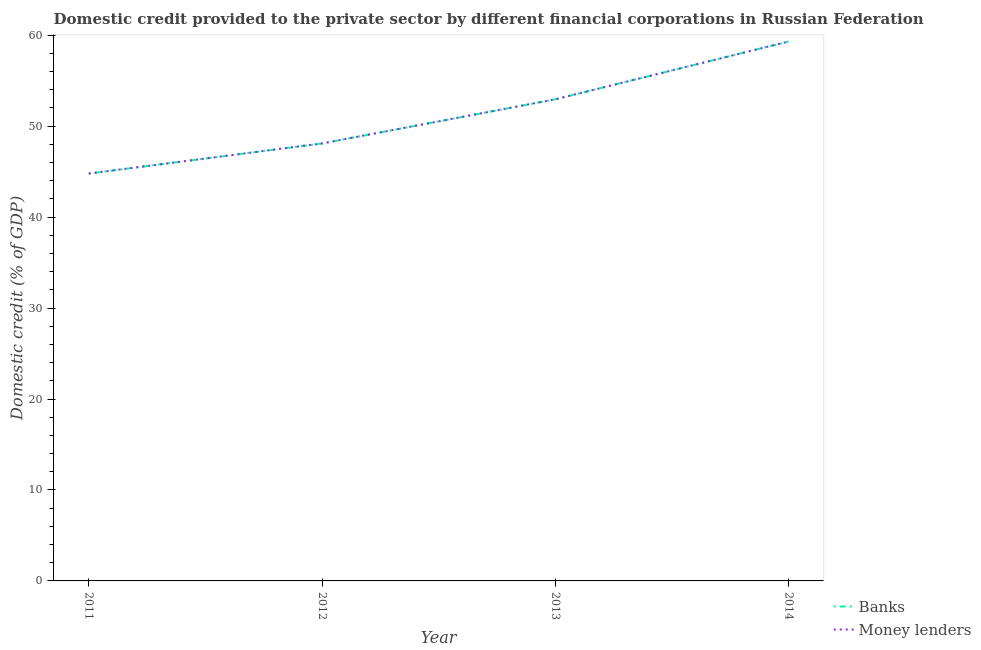What is the domestic credit provided by money lenders in 2013?
Your response must be concise. 52.96. Across all years, what is the maximum domestic credit provided by money lenders?
Ensure brevity in your answer.  59.31. Across all years, what is the minimum domestic credit provided by money lenders?
Keep it short and to the point. 44.79. What is the total domestic credit provided by money lenders in the graph?
Ensure brevity in your answer.  205.15. What is the difference between the domestic credit provided by money lenders in 2011 and that in 2013?
Make the answer very short. -8.17. What is the difference between the domestic credit provided by money lenders in 2012 and the domestic credit provided by banks in 2014?
Offer a terse response. -11.21. What is the average domestic credit provided by banks per year?
Offer a very short reply. 51.29. In the year 2013, what is the difference between the domestic credit provided by banks and domestic credit provided by money lenders?
Your answer should be compact. -0. What is the ratio of the domestic credit provided by money lenders in 2012 to that in 2014?
Keep it short and to the point. 0.81. Is the difference between the domestic credit provided by money lenders in 2012 and 2014 greater than the difference between the domestic credit provided by banks in 2012 and 2014?
Ensure brevity in your answer.  Yes. What is the difference between the highest and the second highest domestic credit provided by money lenders?
Ensure brevity in your answer.  6.35. What is the difference between the highest and the lowest domestic credit provided by banks?
Give a very brief answer. 14.52. In how many years, is the domestic credit provided by banks greater than the average domestic credit provided by banks taken over all years?
Provide a short and direct response. 2. Is the sum of the domestic credit provided by money lenders in 2012 and 2013 greater than the maximum domestic credit provided by banks across all years?
Provide a succinct answer. Yes. Does the domestic credit provided by banks monotonically increase over the years?
Give a very brief answer. Yes. Is the domestic credit provided by banks strictly greater than the domestic credit provided by money lenders over the years?
Provide a succinct answer. No. How many years are there in the graph?
Ensure brevity in your answer.  4. What is the difference between two consecutive major ticks on the Y-axis?
Ensure brevity in your answer.  10. Does the graph contain any zero values?
Offer a very short reply. No. Does the graph contain grids?
Offer a very short reply. No. How many legend labels are there?
Give a very brief answer. 2. What is the title of the graph?
Provide a succinct answer. Domestic credit provided to the private sector by different financial corporations in Russian Federation. What is the label or title of the X-axis?
Provide a succinct answer. Year. What is the label or title of the Y-axis?
Your answer should be compact. Domestic credit (% of GDP). What is the Domestic credit (% of GDP) in Banks in 2011?
Your answer should be very brief. 44.79. What is the Domestic credit (% of GDP) of Money lenders in 2011?
Your answer should be compact. 44.79. What is the Domestic credit (% of GDP) of Banks in 2012?
Ensure brevity in your answer.  48.1. What is the Domestic credit (% of GDP) in Money lenders in 2012?
Ensure brevity in your answer.  48.1. What is the Domestic credit (% of GDP) in Banks in 2013?
Offer a terse response. 52.95. What is the Domestic credit (% of GDP) in Money lenders in 2013?
Ensure brevity in your answer.  52.96. What is the Domestic credit (% of GDP) of Banks in 2014?
Provide a succinct answer. 59.31. What is the Domestic credit (% of GDP) of Money lenders in 2014?
Ensure brevity in your answer.  59.31. Across all years, what is the maximum Domestic credit (% of GDP) in Banks?
Your answer should be compact. 59.31. Across all years, what is the maximum Domestic credit (% of GDP) in Money lenders?
Your response must be concise. 59.31. Across all years, what is the minimum Domestic credit (% of GDP) in Banks?
Keep it short and to the point. 44.79. Across all years, what is the minimum Domestic credit (% of GDP) in Money lenders?
Provide a succinct answer. 44.79. What is the total Domestic credit (% of GDP) in Banks in the graph?
Ensure brevity in your answer.  205.14. What is the total Domestic credit (% of GDP) in Money lenders in the graph?
Offer a terse response. 205.15. What is the difference between the Domestic credit (% of GDP) in Banks in 2011 and that in 2012?
Offer a terse response. -3.31. What is the difference between the Domestic credit (% of GDP) of Money lenders in 2011 and that in 2012?
Your answer should be compact. -3.31. What is the difference between the Domestic credit (% of GDP) of Banks in 2011 and that in 2013?
Ensure brevity in your answer.  -8.17. What is the difference between the Domestic credit (% of GDP) in Money lenders in 2011 and that in 2013?
Ensure brevity in your answer.  -8.17. What is the difference between the Domestic credit (% of GDP) of Banks in 2011 and that in 2014?
Provide a succinct answer. -14.52. What is the difference between the Domestic credit (% of GDP) of Money lenders in 2011 and that in 2014?
Provide a succinct answer. -14.52. What is the difference between the Domestic credit (% of GDP) of Banks in 2012 and that in 2013?
Provide a succinct answer. -4.86. What is the difference between the Domestic credit (% of GDP) of Money lenders in 2012 and that in 2013?
Your response must be concise. -4.86. What is the difference between the Domestic credit (% of GDP) in Banks in 2012 and that in 2014?
Ensure brevity in your answer.  -11.21. What is the difference between the Domestic credit (% of GDP) in Money lenders in 2012 and that in 2014?
Make the answer very short. -11.21. What is the difference between the Domestic credit (% of GDP) of Banks in 2013 and that in 2014?
Keep it short and to the point. -6.35. What is the difference between the Domestic credit (% of GDP) in Money lenders in 2013 and that in 2014?
Ensure brevity in your answer.  -6.35. What is the difference between the Domestic credit (% of GDP) of Banks in 2011 and the Domestic credit (% of GDP) of Money lenders in 2012?
Give a very brief answer. -3.31. What is the difference between the Domestic credit (% of GDP) in Banks in 2011 and the Domestic credit (% of GDP) in Money lenders in 2013?
Your answer should be compact. -8.17. What is the difference between the Domestic credit (% of GDP) in Banks in 2011 and the Domestic credit (% of GDP) in Money lenders in 2014?
Provide a succinct answer. -14.52. What is the difference between the Domestic credit (% of GDP) of Banks in 2012 and the Domestic credit (% of GDP) of Money lenders in 2013?
Your response must be concise. -4.86. What is the difference between the Domestic credit (% of GDP) in Banks in 2012 and the Domestic credit (% of GDP) in Money lenders in 2014?
Provide a succinct answer. -11.21. What is the difference between the Domestic credit (% of GDP) of Banks in 2013 and the Domestic credit (% of GDP) of Money lenders in 2014?
Your response must be concise. -6.36. What is the average Domestic credit (% of GDP) in Banks per year?
Provide a succinct answer. 51.29. What is the average Domestic credit (% of GDP) in Money lenders per year?
Offer a very short reply. 51.29. In the year 2011, what is the difference between the Domestic credit (% of GDP) in Banks and Domestic credit (% of GDP) in Money lenders?
Provide a succinct answer. -0. In the year 2012, what is the difference between the Domestic credit (% of GDP) of Banks and Domestic credit (% of GDP) of Money lenders?
Your response must be concise. -0. In the year 2013, what is the difference between the Domestic credit (% of GDP) of Banks and Domestic credit (% of GDP) of Money lenders?
Offer a very short reply. -0. In the year 2014, what is the difference between the Domestic credit (% of GDP) of Banks and Domestic credit (% of GDP) of Money lenders?
Your answer should be very brief. -0. What is the ratio of the Domestic credit (% of GDP) of Banks in 2011 to that in 2012?
Ensure brevity in your answer.  0.93. What is the ratio of the Domestic credit (% of GDP) in Money lenders in 2011 to that in 2012?
Provide a short and direct response. 0.93. What is the ratio of the Domestic credit (% of GDP) of Banks in 2011 to that in 2013?
Your answer should be compact. 0.85. What is the ratio of the Domestic credit (% of GDP) in Money lenders in 2011 to that in 2013?
Your answer should be very brief. 0.85. What is the ratio of the Domestic credit (% of GDP) in Banks in 2011 to that in 2014?
Offer a very short reply. 0.76. What is the ratio of the Domestic credit (% of GDP) in Money lenders in 2011 to that in 2014?
Ensure brevity in your answer.  0.76. What is the ratio of the Domestic credit (% of GDP) in Banks in 2012 to that in 2013?
Offer a terse response. 0.91. What is the ratio of the Domestic credit (% of GDP) of Money lenders in 2012 to that in 2013?
Keep it short and to the point. 0.91. What is the ratio of the Domestic credit (% of GDP) in Banks in 2012 to that in 2014?
Make the answer very short. 0.81. What is the ratio of the Domestic credit (% of GDP) of Money lenders in 2012 to that in 2014?
Give a very brief answer. 0.81. What is the ratio of the Domestic credit (% of GDP) in Banks in 2013 to that in 2014?
Your answer should be very brief. 0.89. What is the ratio of the Domestic credit (% of GDP) of Money lenders in 2013 to that in 2014?
Provide a succinct answer. 0.89. What is the difference between the highest and the second highest Domestic credit (% of GDP) in Banks?
Ensure brevity in your answer.  6.35. What is the difference between the highest and the second highest Domestic credit (% of GDP) in Money lenders?
Your response must be concise. 6.35. What is the difference between the highest and the lowest Domestic credit (% of GDP) of Banks?
Offer a terse response. 14.52. What is the difference between the highest and the lowest Domestic credit (% of GDP) of Money lenders?
Offer a terse response. 14.52. 